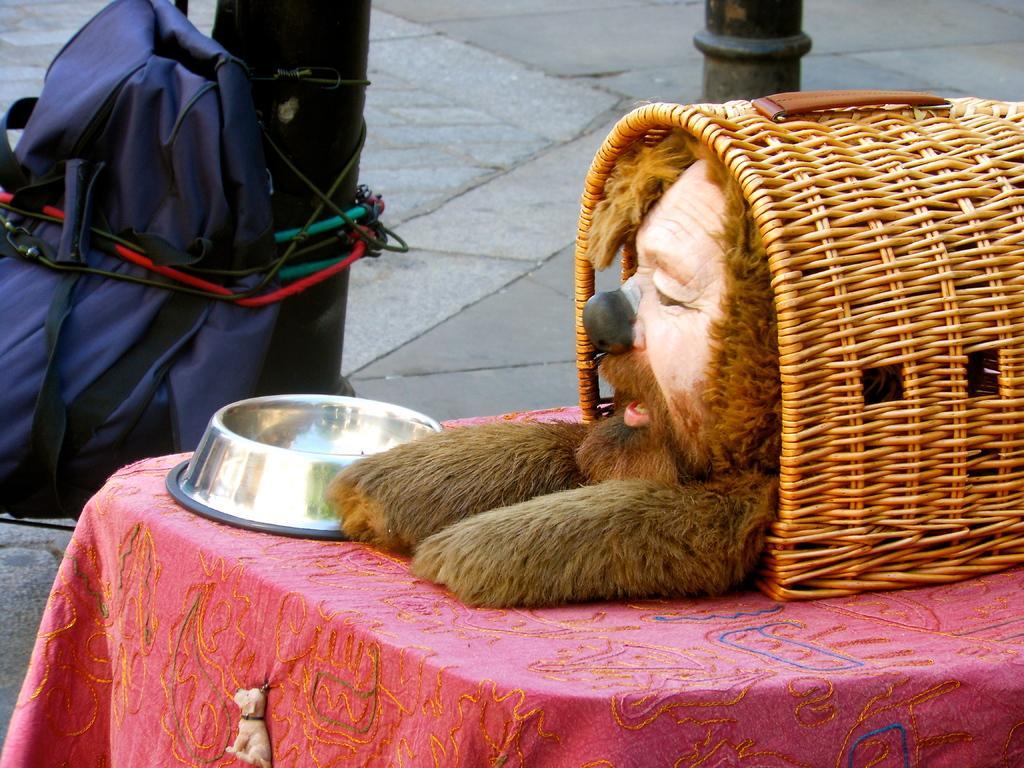Can you describe this image briefly? In this image we can see a table with a tablecloth. On that we can see a person face. Also there is a basket. Near to that there is a plate. In the back there are poles. And a bag is tied to the pole with a rope. 